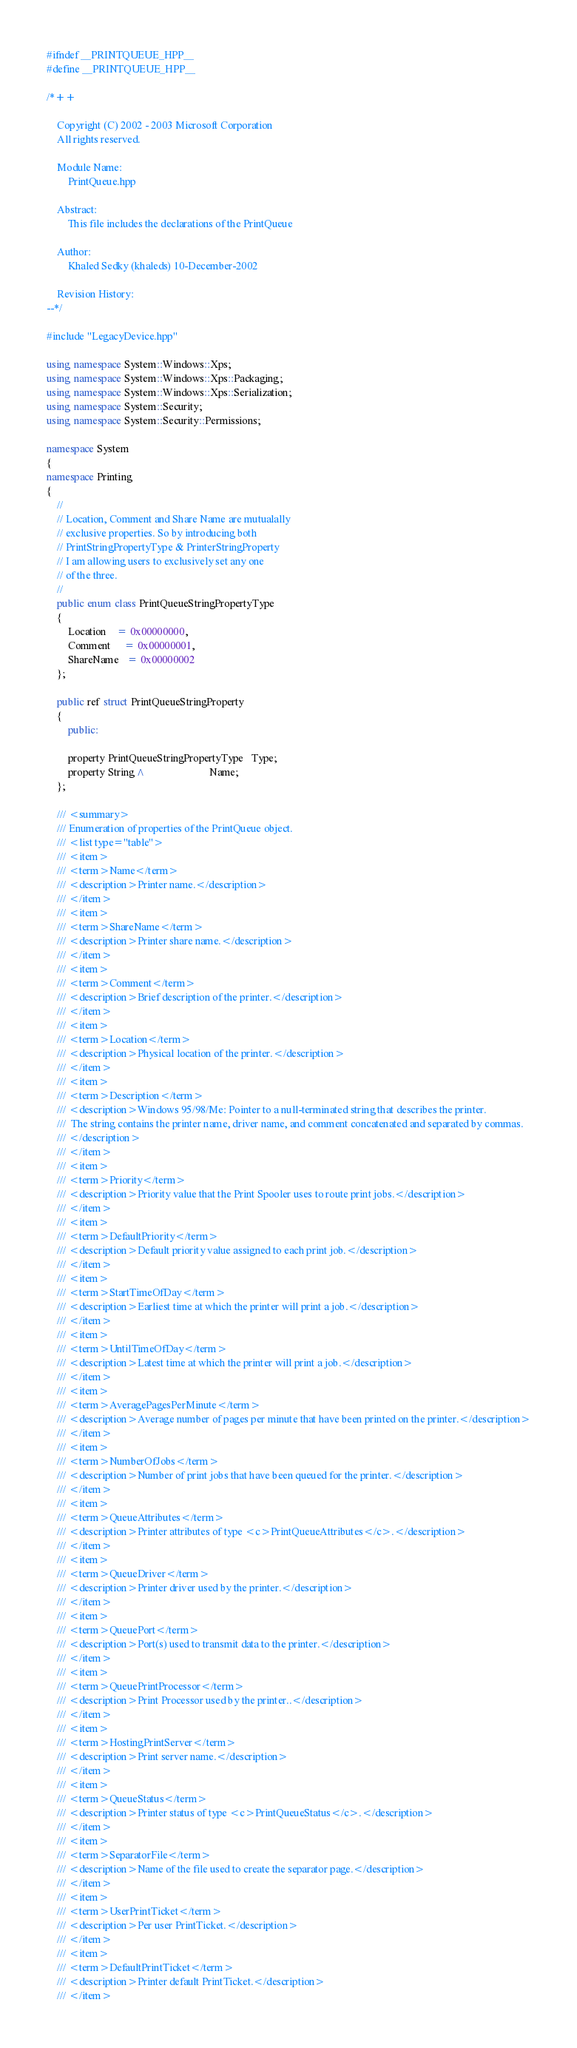<code> <loc_0><loc_0><loc_500><loc_500><_C++_>#ifndef __PRINTQUEUE_HPP__
#define __PRINTQUEUE_HPP__

/*++

    Copyright (C) 2002 - 2003 Microsoft Corporation
    All rights reserved.

    Module Name:
        PrintQueue.hpp

    Abstract:
        This file includes the declarations of the PrintQueue

    Author:
        Khaled Sedky (khaleds) 10-December-2002

    Revision History:
--*/

#include "LegacyDevice.hpp"

using namespace System::Windows::Xps;
using namespace System::Windows::Xps::Packaging;
using namespace System::Windows::Xps::Serialization;
using namespace System::Security;
using namespace System::Security::Permissions;

namespace System
{
namespace Printing
{
    //
    // Location, Comment and Share Name are mutualally
    // exclusive properties. So by introducing both
    // PrintStringPropertyType & PrinterStringProperty
    // I am allowing users to exclusively set any one
    // of the three.
    //
    public enum class PrintQueueStringPropertyType
    {
        Location    = 0x00000000,
        Comment     = 0x00000001,
        ShareName   = 0x00000002
    };

    public ref struct PrintQueueStringProperty
    {
        public:

        property PrintQueueStringPropertyType   Type;
        property String^                        Name;
    };

    /// <summary>
    /// Enumeration of properties of the PrintQueue object.
    /// <list type="table">
    /// <item>
    /// <term>Name</term>
    /// <description>Printer name.</description>
    /// </item>
    /// <item>
    /// <term>ShareName</term>
    /// <description>Printer share name.</description>
    /// </item>
    /// <item>
    /// <term>Comment</term>
    /// <description>Brief description of the printer.</description>
    /// </item>
    /// <item>
    /// <term>Location</term>
    /// <description>Physical location of the printer.</description>
    /// </item>
    /// <item>
    /// <term>Description</term>
    /// <description>Windows 95/98/Me: Pointer to a null-terminated string that describes the printer.
    ///  The string contains the printer name, driver name, and comment concatenated and separated by commas.
    /// </description>
    /// </item>
    /// <item>
    /// <term>Priority</term>
    /// <description>Priority value that the Print Spooler uses to route print jobs.</description>
    /// </item>
    /// <item>
    /// <term>DefaultPriority</term>
    /// <description>Default priority value assigned to each print job.</description>
    /// </item>
    /// <item>
    /// <term>StartTimeOfDay</term>
    /// <description>Earliest time at which the printer will print a job.</description>
    /// </item>
    /// <item>
    /// <term>UntilTimeOfDay</term>
    /// <description>Latest time at which the printer will print a job.</description>
    /// </item>
    /// <item>
    /// <term>AveragePagesPerMinute</term>
    /// <description>Average number of pages per minute that have been printed on the printer.</description>
    /// </item>
    /// <item>
    /// <term>NumberOfJobs</term>
    /// <description>Number of print jobs that have been queued for the printer.</description>
    /// </item>
    /// <item>
    /// <term>QueueAttributes</term>
    /// <description>Printer attributes of type <c>PrintQueueAttributes</c>.</description>
    /// </item>
    /// <item>
    /// <term>QueueDriver</term>
    /// <description>Printer driver used by the printer.</description>
    /// </item>
    /// <item>
    /// <term>QueuePort</term>
    /// <description>Port(s) used to transmit data to the printer.</description>
    /// </item>
    /// <item>
    /// <term>QueuePrintProcessor</term>
    /// <description>Print Processor used by the printer..</description>
    /// </item>
    /// <item>
    /// <term>HostingPrintServer</term>
    /// <description>Print server name.</description>
    /// </item>
    /// <item>
    /// <term>QueueStatus</term>
    /// <description>Printer status of type <c>PrintQueueStatus</c>.</description>
    /// </item>
    /// <item>
    /// <term>SeparatorFile</term>
    /// <description>Name of the file used to create the separator page.</description>
    /// </item>
    /// <item>
    /// <term>UserPrintTicket</term>
    /// <description>Per user PrintTicket.</description>
    /// </item>
    /// <item>
    /// <term>DefaultPrintTicket</term>
    /// <description>Printer default PrintTicket.</description>
    /// </item></code> 